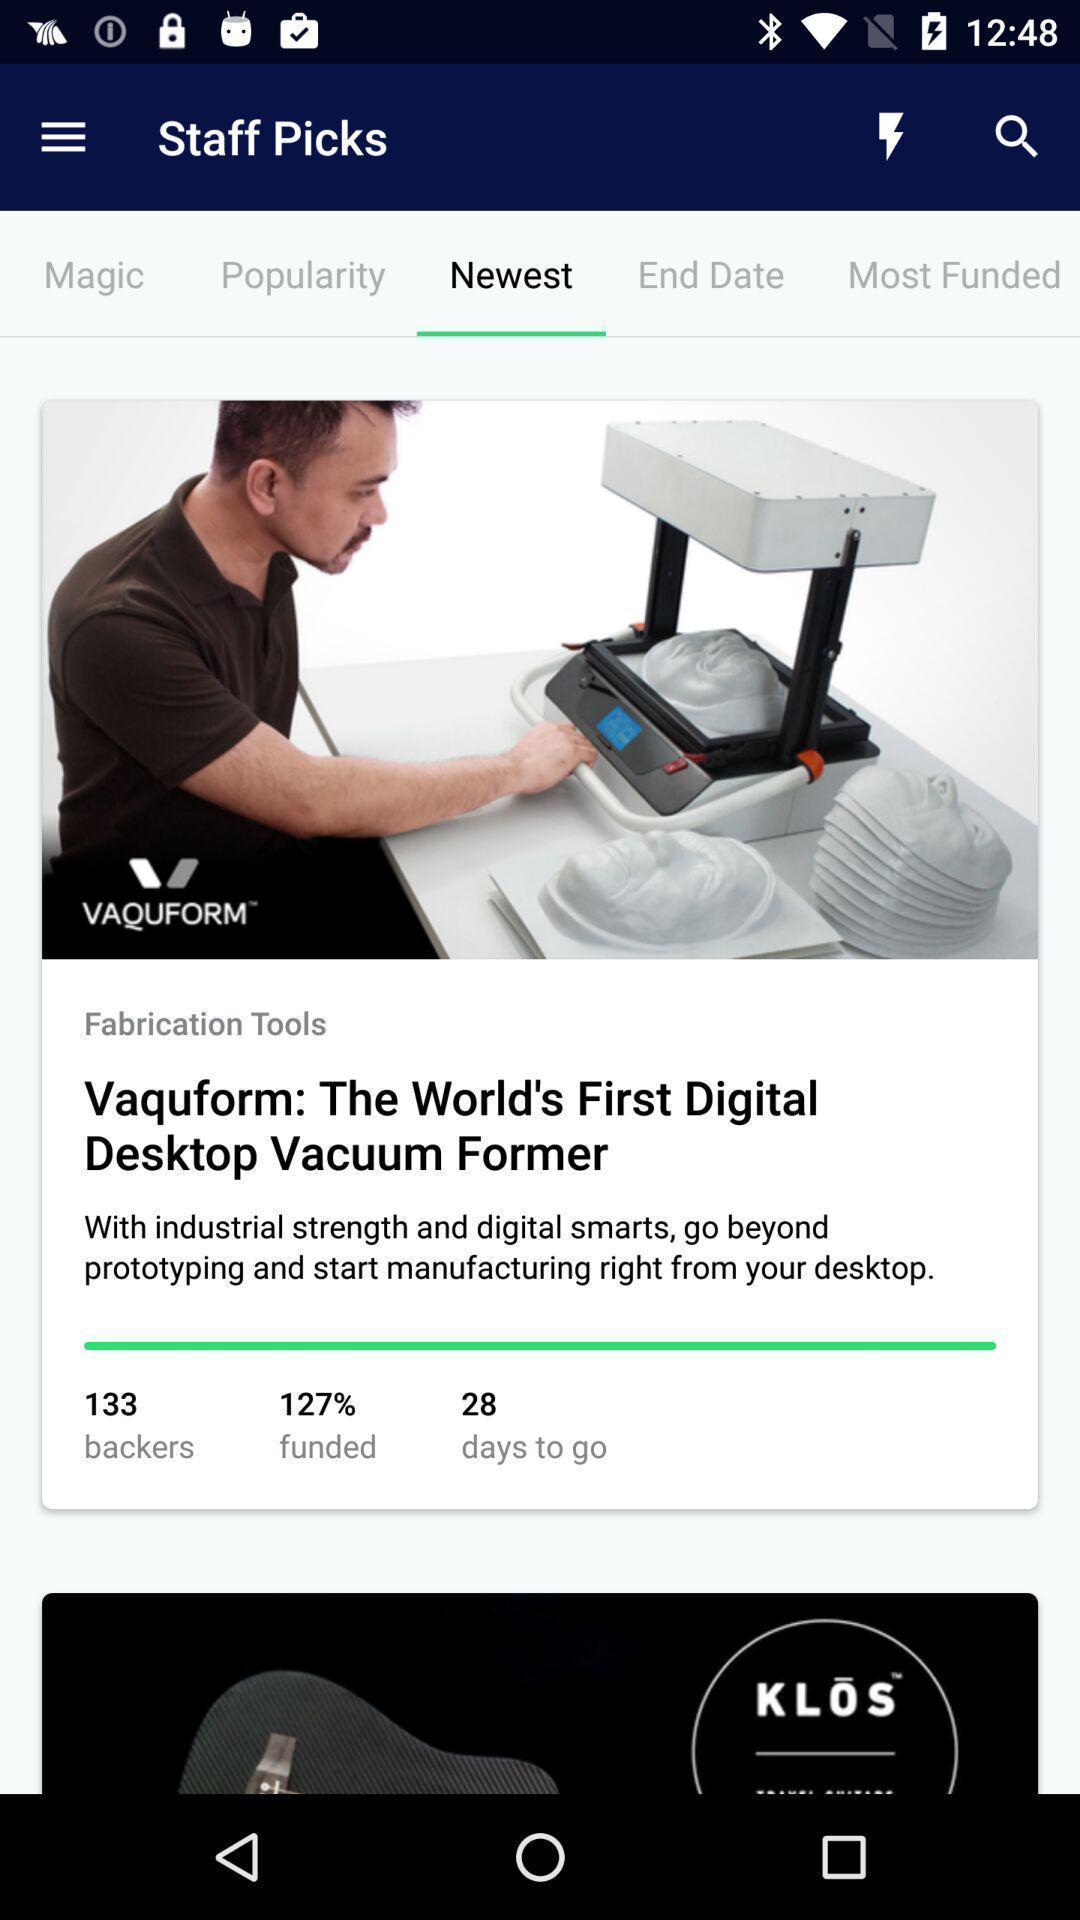What can you discern from this picture? Screen displaying about digital desktop. 